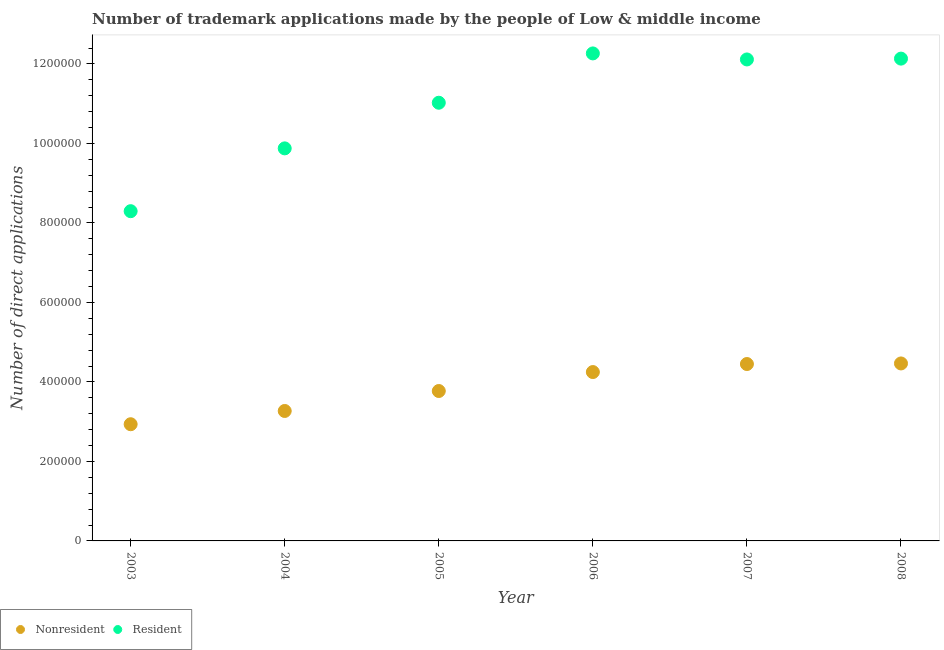Is the number of dotlines equal to the number of legend labels?
Your answer should be very brief. Yes. What is the number of trademark applications made by residents in 2003?
Provide a succinct answer. 8.30e+05. Across all years, what is the maximum number of trademark applications made by non residents?
Provide a succinct answer. 4.47e+05. Across all years, what is the minimum number of trademark applications made by non residents?
Ensure brevity in your answer.  2.94e+05. In which year was the number of trademark applications made by residents maximum?
Your response must be concise. 2006. What is the total number of trademark applications made by non residents in the graph?
Your response must be concise. 2.31e+06. What is the difference between the number of trademark applications made by residents in 2004 and that in 2006?
Give a very brief answer. -2.39e+05. What is the difference between the number of trademark applications made by residents in 2003 and the number of trademark applications made by non residents in 2005?
Provide a short and direct response. 4.52e+05. What is the average number of trademark applications made by residents per year?
Your answer should be compact. 1.10e+06. In the year 2005, what is the difference between the number of trademark applications made by non residents and number of trademark applications made by residents?
Provide a succinct answer. -7.25e+05. In how many years, is the number of trademark applications made by non residents greater than 600000?
Provide a short and direct response. 0. What is the ratio of the number of trademark applications made by residents in 2003 to that in 2008?
Ensure brevity in your answer.  0.68. Is the difference between the number of trademark applications made by non residents in 2004 and 2006 greater than the difference between the number of trademark applications made by residents in 2004 and 2006?
Offer a very short reply. Yes. What is the difference between the highest and the second highest number of trademark applications made by residents?
Give a very brief answer. 1.31e+04. What is the difference between the highest and the lowest number of trademark applications made by non residents?
Your answer should be very brief. 1.53e+05. In how many years, is the number of trademark applications made by non residents greater than the average number of trademark applications made by non residents taken over all years?
Provide a short and direct response. 3. Is the number of trademark applications made by non residents strictly greater than the number of trademark applications made by residents over the years?
Your response must be concise. No. Is the number of trademark applications made by non residents strictly less than the number of trademark applications made by residents over the years?
Keep it short and to the point. Yes. How many dotlines are there?
Your response must be concise. 2. What is the difference between two consecutive major ticks on the Y-axis?
Your answer should be compact. 2.00e+05. Are the values on the major ticks of Y-axis written in scientific E-notation?
Offer a very short reply. No. Does the graph contain grids?
Give a very brief answer. No. How are the legend labels stacked?
Make the answer very short. Horizontal. What is the title of the graph?
Keep it short and to the point. Number of trademark applications made by the people of Low & middle income. What is the label or title of the X-axis?
Offer a very short reply. Year. What is the label or title of the Y-axis?
Offer a very short reply. Number of direct applications. What is the Number of direct applications of Nonresident in 2003?
Ensure brevity in your answer.  2.94e+05. What is the Number of direct applications in Resident in 2003?
Provide a short and direct response. 8.30e+05. What is the Number of direct applications in Nonresident in 2004?
Your response must be concise. 3.27e+05. What is the Number of direct applications in Resident in 2004?
Keep it short and to the point. 9.88e+05. What is the Number of direct applications of Nonresident in 2005?
Provide a succinct answer. 3.77e+05. What is the Number of direct applications in Resident in 2005?
Give a very brief answer. 1.10e+06. What is the Number of direct applications in Nonresident in 2006?
Make the answer very short. 4.25e+05. What is the Number of direct applications in Resident in 2006?
Provide a succinct answer. 1.23e+06. What is the Number of direct applications of Nonresident in 2007?
Offer a very short reply. 4.45e+05. What is the Number of direct applications of Resident in 2007?
Keep it short and to the point. 1.21e+06. What is the Number of direct applications in Nonresident in 2008?
Provide a succinct answer. 4.47e+05. What is the Number of direct applications in Resident in 2008?
Give a very brief answer. 1.21e+06. Across all years, what is the maximum Number of direct applications in Nonresident?
Your response must be concise. 4.47e+05. Across all years, what is the maximum Number of direct applications of Resident?
Your response must be concise. 1.23e+06. Across all years, what is the minimum Number of direct applications of Nonresident?
Ensure brevity in your answer.  2.94e+05. Across all years, what is the minimum Number of direct applications in Resident?
Give a very brief answer. 8.30e+05. What is the total Number of direct applications of Nonresident in the graph?
Provide a short and direct response. 2.31e+06. What is the total Number of direct applications of Resident in the graph?
Keep it short and to the point. 6.57e+06. What is the difference between the Number of direct applications of Nonresident in 2003 and that in 2004?
Keep it short and to the point. -3.34e+04. What is the difference between the Number of direct applications of Resident in 2003 and that in 2004?
Ensure brevity in your answer.  -1.58e+05. What is the difference between the Number of direct applications of Nonresident in 2003 and that in 2005?
Provide a short and direct response. -8.36e+04. What is the difference between the Number of direct applications in Resident in 2003 and that in 2005?
Make the answer very short. -2.73e+05. What is the difference between the Number of direct applications of Nonresident in 2003 and that in 2006?
Give a very brief answer. -1.31e+05. What is the difference between the Number of direct applications in Resident in 2003 and that in 2006?
Your answer should be very brief. -3.97e+05. What is the difference between the Number of direct applications in Nonresident in 2003 and that in 2007?
Provide a succinct answer. -1.51e+05. What is the difference between the Number of direct applications in Resident in 2003 and that in 2007?
Ensure brevity in your answer.  -3.82e+05. What is the difference between the Number of direct applications of Nonresident in 2003 and that in 2008?
Give a very brief answer. -1.53e+05. What is the difference between the Number of direct applications in Resident in 2003 and that in 2008?
Your response must be concise. -3.84e+05. What is the difference between the Number of direct applications in Nonresident in 2004 and that in 2005?
Keep it short and to the point. -5.02e+04. What is the difference between the Number of direct applications of Resident in 2004 and that in 2005?
Your answer should be compact. -1.15e+05. What is the difference between the Number of direct applications of Nonresident in 2004 and that in 2006?
Keep it short and to the point. -9.79e+04. What is the difference between the Number of direct applications of Resident in 2004 and that in 2006?
Your answer should be compact. -2.39e+05. What is the difference between the Number of direct applications of Nonresident in 2004 and that in 2007?
Your answer should be very brief. -1.18e+05. What is the difference between the Number of direct applications of Resident in 2004 and that in 2007?
Provide a short and direct response. -2.24e+05. What is the difference between the Number of direct applications in Nonresident in 2004 and that in 2008?
Keep it short and to the point. -1.20e+05. What is the difference between the Number of direct applications of Resident in 2004 and that in 2008?
Your response must be concise. -2.26e+05. What is the difference between the Number of direct applications in Nonresident in 2005 and that in 2006?
Your response must be concise. -4.77e+04. What is the difference between the Number of direct applications in Resident in 2005 and that in 2006?
Make the answer very short. -1.24e+05. What is the difference between the Number of direct applications in Nonresident in 2005 and that in 2007?
Ensure brevity in your answer.  -6.79e+04. What is the difference between the Number of direct applications of Resident in 2005 and that in 2007?
Offer a terse response. -1.09e+05. What is the difference between the Number of direct applications in Nonresident in 2005 and that in 2008?
Provide a succinct answer. -6.93e+04. What is the difference between the Number of direct applications in Resident in 2005 and that in 2008?
Provide a short and direct response. -1.11e+05. What is the difference between the Number of direct applications in Nonresident in 2006 and that in 2007?
Provide a succinct answer. -2.02e+04. What is the difference between the Number of direct applications in Resident in 2006 and that in 2007?
Ensure brevity in your answer.  1.52e+04. What is the difference between the Number of direct applications in Nonresident in 2006 and that in 2008?
Keep it short and to the point. -2.16e+04. What is the difference between the Number of direct applications in Resident in 2006 and that in 2008?
Offer a very short reply. 1.31e+04. What is the difference between the Number of direct applications in Nonresident in 2007 and that in 2008?
Your answer should be compact. -1451. What is the difference between the Number of direct applications of Resident in 2007 and that in 2008?
Your response must be concise. -2081. What is the difference between the Number of direct applications of Nonresident in 2003 and the Number of direct applications of Resident in 2004?
Keep it short and to the point. -6.94e+05. What is the difference between the Number of direct applications in Nonresident in 2003 and the Number of direct applications in Resident in 2005?
Ensure brevity in your answer.  -8.09e+05. What is the difference between the Number of direct applications in Nonresident in 2003 and the Number of direct applications in Resident in 2006?
Offer a terse response. -9.33e+05. What is the difference between the Number of direct applications of Nonresident in 2003 and the Number of direct applications of Resident in 2007?
Ensure brevity in your answer.  -9.18e+05. What is the difference between the Number of direct applications in Nonresident in 2003 and the Number of direct applications in Resident in 2008?
Offer a terse response. -9.20e+05. What is the difference between the Number of direct applications in Nonresident in 2004 and the Number of direct applications in Resident in 2005?
Keep it short and to the point. -7.76e+05. What is the difference between the Number of direct applications of Nonresident in 2004 and the Number of direct applications of Resident in 2006?
Your answer should be very brief. -9.00e+05. What is the difference between the Number of direct applications of Nonresident in 2004 and the Number of direct applications of Resident in 2007?
Make the answer very short. -8.84e+05. What is the difference between the Number of direct applications in Nonresident in 2004 and the Number of direct applications in Resident in 2008?
Ensure brevity in your answer.  -8.87e+05. What is the difference between the Number of direct applications of Nonresident in 2005 and the Number of direct applications of Resident in 2006?
Give a very brief answer. -8.49e+05. What is the difference between the Number of direct applications in Nonresident in 2005 and the Number of direct applications in Resident in 2007?
Keep it short and to the point. -8.34e+05. What is the difference between the Number of direct applications in Nonresident in 2005 and the Number of direct applications in Resident in 2008?
Make the answer very short. -8.36e+05. What is the difference between the Number of direct applications in Nonresident in 2006 and the Number of direct applications in Resident in 2007?
Make the answer very short. -7.87e+05. What is the difference between the Number of direct applications in Nonresident in 2006 and the Number of direct applications in Resident in 2008?
Offer a very short reply. -7.89e+05. What is the difference between the Number of direct applications of Nonresident in 2007 and the Number of direct applications of Resident in 2008?
Provide a short and direct response. -7.68e+05. What is the average Number of direct applications in Nonresident per year?
Your answer should be compact. 3.86e+05. What is the average Number of direct applications of Resident per year?
Ensure brevity in your answer.  1.10e+06. In the year 2003, what is the difference between the Number of direct applications of Nonresident and Number of direct applications of Resident?
Ensure brevity in your answer.  -5.36e+05. In the year 2004, what is the difference between the Number of direct applications of Nonresident and Number of direct applications of Resident?
Offer a terse response. -6.61e+05. In the year 2005, what is the difference between the Number of direct applications in Nonresident and Number of direct applications in Resident?
Ensure brevity in your answer.  -7.25e+05. In the year 2006, what is the difference between the Number of direct applications in Nonresident and Number of direct applications in Resident?
Your answer should be very brief. -8.02e+05. In the year 2007, what is the difference between the Number of direct applications of Nonresident and Number of direct applications of Resident?
Your answer should be compact. -7.66e+05. In the year 2008, what is the difference between the Number of direct applications of Nonresident and Number of direct applications of Resident?
Offer a terse response. -7.67e+05. What is the ratio of the Number of direct applications of Nonresident in 2003 to that in 2004?
Ensure brevity in your answer.  0.9. What is the ratio of the Number of direct applications of Resident in 2003 to that in 2004?
Your answer should be very brief. 0.84. What is the ratio of the Number of direct applications in Nonresident in 2003 to that in 2005?
Provide a succinct answer. 0.78. What is the ratio of the Number of direct applications of Resident in 2003 to that in 2005?
Provide a succinct answer. 0.75. What is the ratio of the Number of direct applications in Nonresident in 2003 to that in 2006?
Offer a very short reply. 0.69. What is the ratio of the Number of direct applications of Resident in 2003 to that in 2006?
Your answer should be compact. 0.68. What is the ratio of the Number of direct applications of Nonresident in 2003 to that in 2007?
Your answer should be compact. 0.66. What is the ratio of the Number of direct applications in Resident in 2003 to that in 2007?
Your response must be concise. 0.68. What is the ratio of the Number of direct applications in Nonresident in 2003 to that in 2008?
Make the answer very short. 0.66. What is the ratio of the Number of direct applications in Resident in 2003 to that in 2008?
Your response must be concise. 0.68. What is the ratio of the Number of direct applications of Nonresident in 2004 to that in 2005?
Your response must be concise. 0.87. What is the ratio of the Number of direct applications of Resident in 2004 to that in 2005?
Ensure brevity in your answer.  0.9. What is the ratio of the Number of direct applications in Nonresident in 2004 to that in 2006?
Offer a very short reply. 0.77. What is the ratio of the Number of direct applications in Resident in 2004 to that in 2006?
Offer a very short reply. 0.81. What is the ratio of the Number of direct applications in Nonresident in 2004 to that in 2007?
Give a very brief answer. 0.73. What is the ratio of the Number of direct applications of Resident in 2004 to that in 2007?
Your answer should be compact. 0.82. What is the ratio of the Number of direct applications in Nonresident in 2004 to that in 2008?
Your response must be concise. 0.73. What is the ratio of the Number of direct applications in Resident in 2004 to that in 2008?
Offer a very short reply. 0.81. What is the ratio of the Number of direct applications in Nonresident in 2005 to that in 2006?
Ensure brevity in your answer.  0.89. What is the ratio of the Number of direct applications of Resident in 2005 to that in 2006?
Keep it short and to the point. 0.9. What is the ratio of the Number of direct applications in Nonresident in 2005 to that in 2007?
Provide a succinct answer. 0.85. What is the ratio of the Number of direct applications in Resident in 2005 to that in 2007?
Your response must be concise. 0.91. What is the ratio of the Number of direct applications of Nonresident in 2005 to that in 2008?
Your answer should be compact. 0.84. What is the ratio of the Number of direct applications of Resident in 2005 to that in 2008?
Make the answer very short. 0.91. What is the ratio of the Number of direct applications of Nonresident in 2006 to that in 2007?
Offer a very short reply. 0.95. What is the ratio of the Number of direct applications of Resident in 2006 to that in 2007?
Keep it short and to the point. 1.01. What is the ratio of the Number of direct applications in Nonresident in 2006 to that in 2008?
Give a very brief answer. 0.95. What is the ratio of the Number of direct applications in Resident in 2006 to that in 2008?
Your answer should be very brief. 1.01. What is the ratio of the Number of direct applications in Nonresident in 2007 to that in 2008?
Make the answer very short. 1. What is the ratio of the Number of direct applications of Resident in 2007 to that in 2008?
Ensure brevity in your answer.  1. What is the difference between the highest and the second highest Number of direct applications in Nonresident?
Keep it short and to the point. 1451. What is the difference between the highest and the second highest Number of direct applications in Resident?
Provide a short and direct response. 1.31e+04. What is the difference between the highest and the lowest Number of direct applications of Nonresident?
Offer a terse response. 1.53e+05. What is the difference between the highest and the lowest Number of direct applications in Resident?
Make the answer very short. 3.97e+05. 